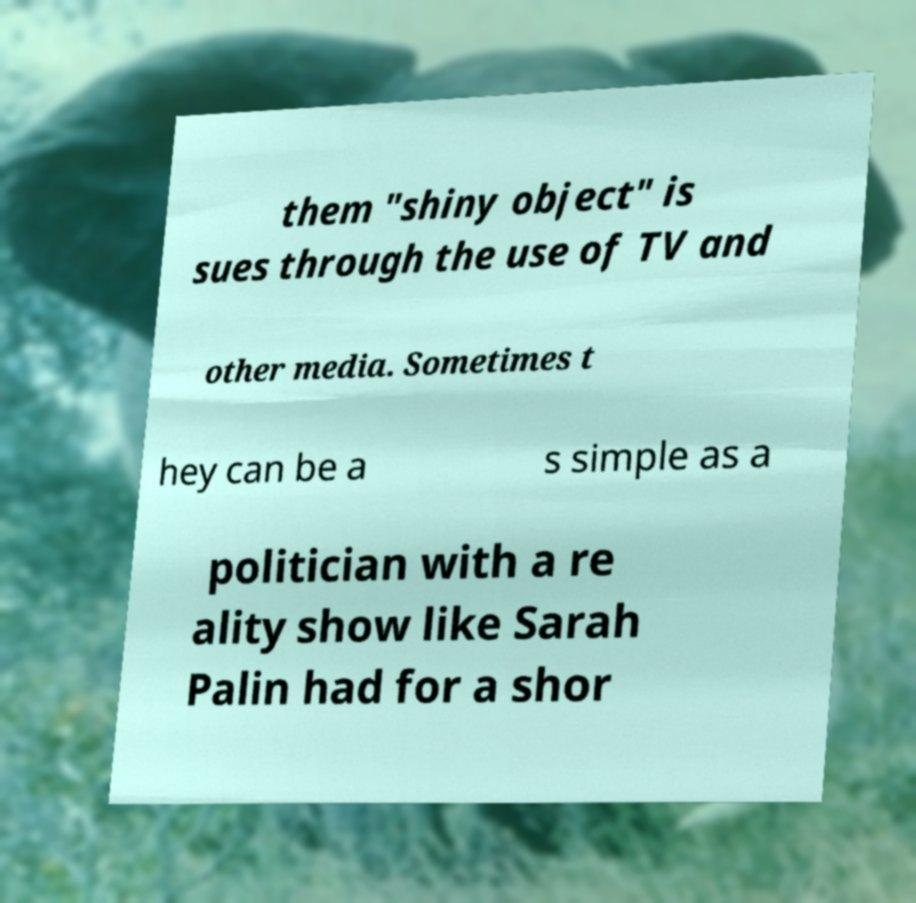What messages or text are displayed in this image? I need them in a readable, typed format. them "shiny object" is sues through the use of TV and other media. Sometimes t hey can be a s simple as a politician with a re ality show like Sarah Palin had for a shor 